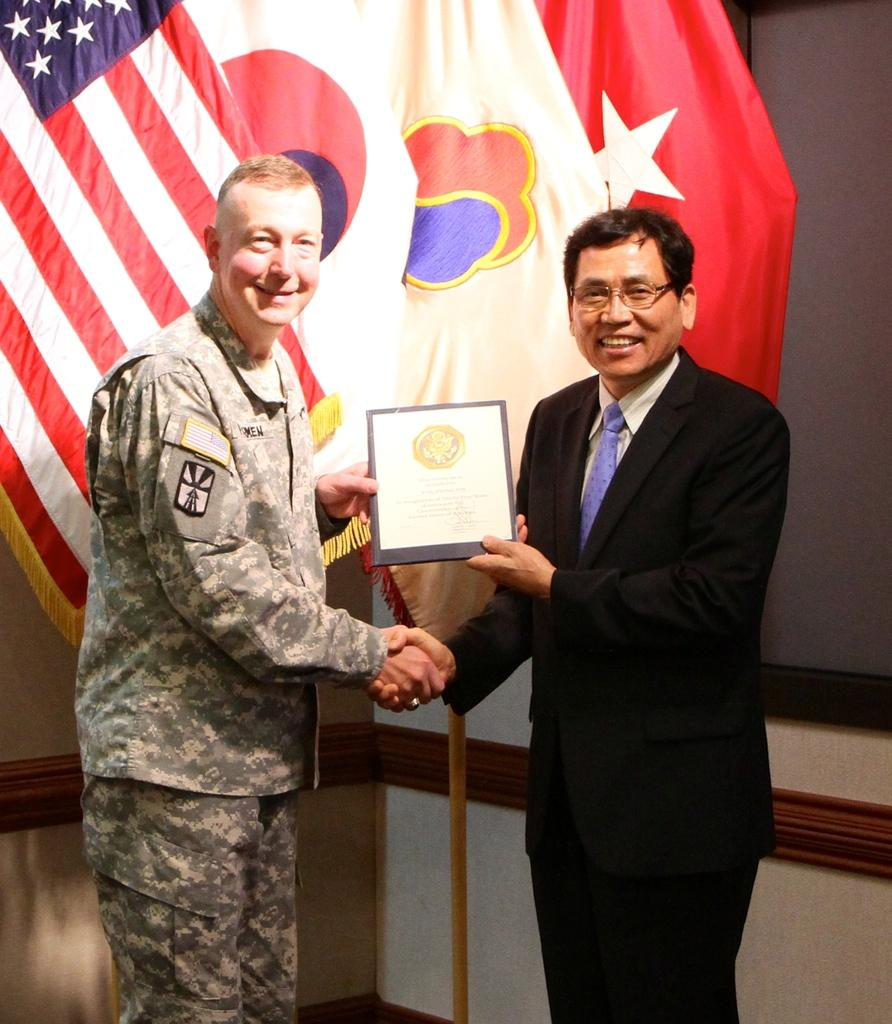How many people are in the image? There are two men in the image. What are the men doing in the image? The men are standing and shaking hands. What object are the men holding in the image? The men are holding a certificate. What can be seen in the background of the image? There are flags in the background of the image. What type of beast can be seen sleeping in the bedroom in the image? There is no beast or bedroom present in the image; it features two men shaking hands and holding a certificate. What dental procedure is being performed on the tooth in the image? There is no tooth or dental procedure present in the image. 